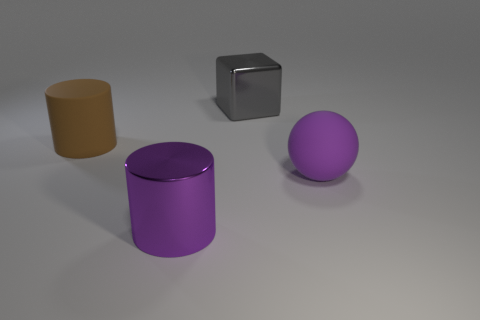There is a large sphere that is the same color as the large metal cylinder; what is its material?
Your response must be concise. Rubber. What shape is the large object that is left of the ball and in front of the large brown thing?
Offer a terse response. Cylinder. Is the material of the big object that is behind the brown cylinder the same as the big purple cylinder?
Ensure brevity in your answer.  Yes. What color is the sphere that is the same size as the block?
Ensure brevity in your answer.  Purple. Are there any objects of the same color as the rubber ball?
Keep it short and to the point. Yes. How many other things are the same size as the ball?
Offer a terse response. 3. What is the material of the large cylinder behind the ball?
Provide a succinct answer. Rubber. What is the shape of the large metallic object that is in front of the purple object on the right side of the large purple shiny object left of the large shiny cube?
Your answer should be compact. Cylinder. How many things are either small purple metal balls or objects on the right side of the large gray metallic block?
Give a very brief answer. 1. How many things are large things that are in front of the big matte sphere or large objects that are in front of the large matte cylinder?
Your answer should be compact. 2. 